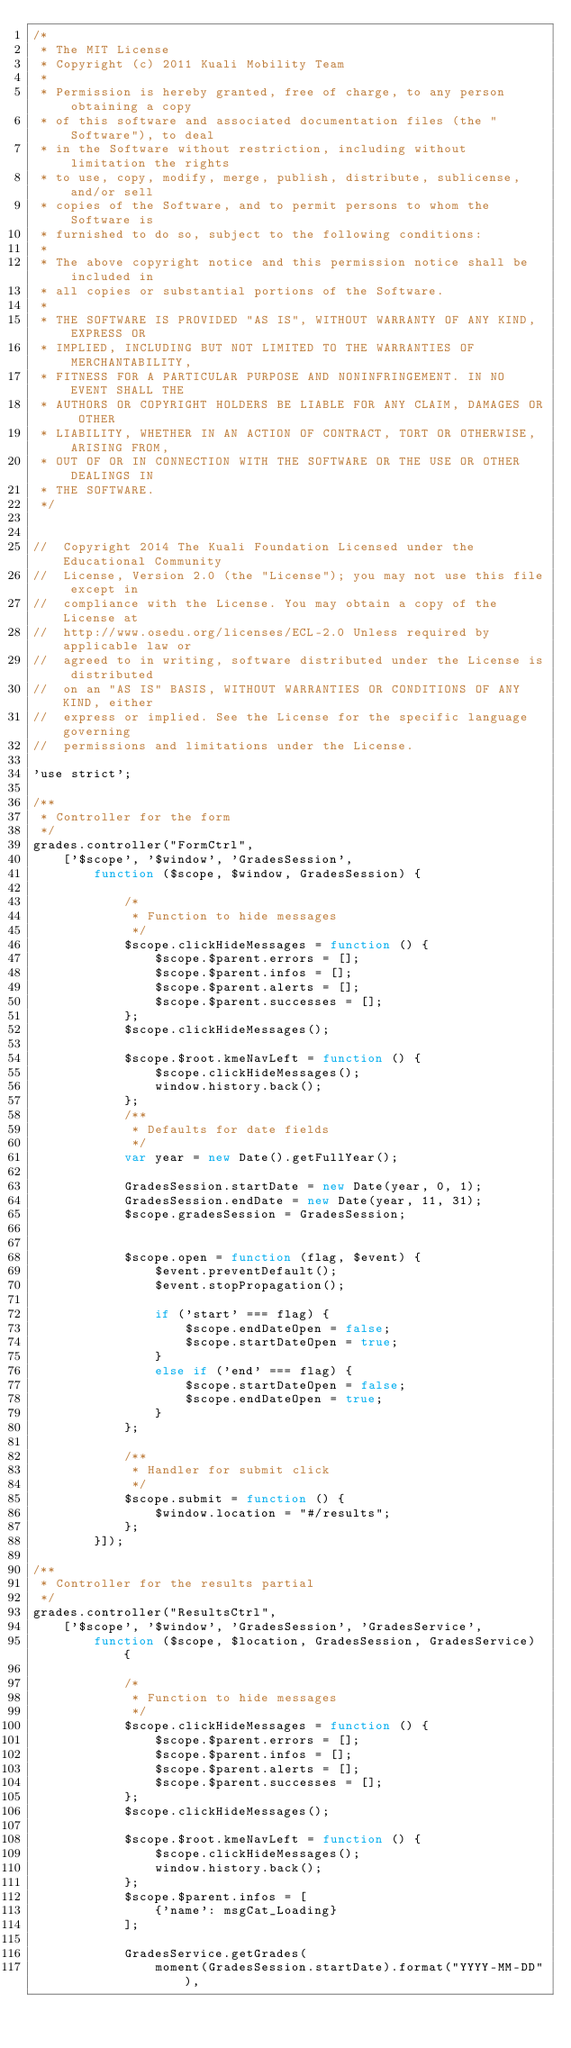<code> <loc_0><loc_0><loc_500><loc_500><_JavaScript_>/*
 * The MIT License
 * Copyright (c) 2011 Kuali Mobility Team
 *
 * Permission is hereby granted, free of charge, to any person obtaining a copy
 * of this software and associated documentation files (the "Software"), to deal
 * in the Software without restriction, including without limitation the rights
 * to use, copy, modify, merge, publish, distribute, sublicense, and/or sell
 * copies of the Software, and to permit persons to whom the Software is
 * furnished to do so, subject to the following conditions:
 *
 * The above copyright notice and this permission notice shall be included in
 * all copies or substantial portions of the Software.
 *
 * THE SOFTWARE IS PROVIDED "AS IS", WITHOUT WARRANTY OF ANY KIND, EXPRESS OR
 * IMPLIED, INCLUDING BUT NOT LIMITED TO THE WARRANTIES OF MERCHANTABILITY,
 * FITNESS FOR A PARTICULAR PURPOSE AND NONINFRINGEMENT. IN NO EVENT SHALL THE
 * AUTHORS OR COPYRIGHT HOLDERS BE LIABLE FOR ANY CLAIM, DAMAGES OR OTHER
 * LIABILITY, WHETHER IN AN ACTION OF CONTRACT, TORT OR OTHERWISE, ARISING FROM,
 * OUT OF OR IN CONNECTION WITH THE SOFTWARE OR THE USE OR OTHER DEALINGS IN
 * THE SOFTWARE.
 */


//  Copyright 2014 The Kuali Foundation Licensed under the Educational Community
//  License, Version 2.0 (the "License"); you may not use this file except in
//  compliance with the License. You may obtain a copy of the License at
//  http://www.osedu.org/licenses/ECL-2.0 Unless required by applicable law or
//  agreed to in writing, software distributed under the License is distributed
//  on an "AS IS" BASIS, WITHOUT WARRANTIES OR CONDITIONS OF ANY KIND, either
//  express or implied. See the License for the specific language governing
//  permissions and limitations under the License.

'use strict';

/**
 * Controller for the form
 */
grades.controller("FormCtrl",
    ['$scope', '$window', 'GradesSession',
        function ($scope, $window, GradesSession) {

            /*
             * Function to hide messages
             */
            $scope.clickHideMessages = function () {
                $scope.$parent.errors = [];
                $scope.$parent.infos = [];
                $scope.$parent.alerts = [];
                $scope.$parent.successes = [];
            };
            $scope.clickHideMessages();

            $scope.$root.kmeNavLeft = function () {
                $scope.clickHideMessages();
                window.history.back();
            };
            /**
             * Defaults for date fields
             */
            var year = new Date().getFullYear();

            GradesSession.startDate = new Date(year, 0, 1);
            GradesSession.endDate = new Date(year, 11, 31);
            $scope.gradesSession = GradesSession;


            $scope.open = function (flag, $event) {
                $event.preventDefault();
                $event.stopPropagation();

                if ('start' === flag) {
                    $scope.endDateOpen = false;
                    $scope.startDateOpen = true;
                }
                else if ('end' === flag) {
                    $scope.startDateOpen = false;
                    $scope.endDateOpen = true;
                }
            };

            /**
             * Handler for submit click
             */
            $scope.submit = function () {
                $window.location = "#/results";
            };
        }]);

/**
 * Controller for the results partial
 */
grades.controller("ResultsCtrl",
    ['$scope', '$window', 'GradesSession', 'GradesService',
        function ($scope, $location, GradesSession, GradesService) {

            /*
             * Function to hide messages
             */
            $scope.clickHideMessages = function () {
                $scope.$parent.errors = [];
                $scope.$parent.infos = [];
                $scope.$parent.alerts = [];
                $scope.$parent.successes = [];
            };
            $scope.clickHideMessages();

            $scope.$root.kmeNavLeft = function () {
                $scope.clickHideMessages();
                window.history.back();
            };
            $scope.$parent.infos = [
                {'name': msgCat_Loading}
            ];

            GradesService.getGrades(
                moment(GradesSession.startDate).format("YYYY-MM-DD"),</code> 